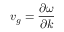Convert formula to latex. <formula><loc_0><loc_0><loc_500><loc_500>v _ { g } = \frac { \partial \omega } { \partial k }</formula> 